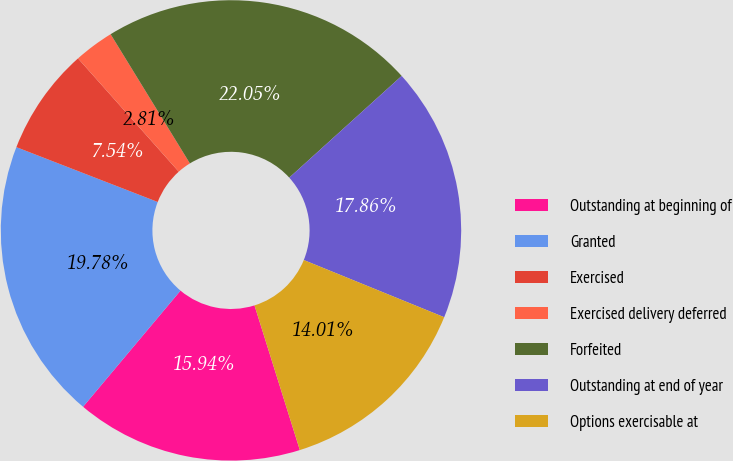Convert chart to OTSL. <chart><loc_0><loc_0><loc_500><loc_500><pie_chart><fcel>Outstanding at beginning of<fcel>Granted<fcel>Exercised<fcel>Exercised delivery deferred<fcel>Forfeited<fcel>Outstanding at end of year<fcel>Options exercisable at<nl><fcel>15.94%<fcel>19.78%<fcel>7.54%<fcel>2.81%<fcel>22.05%<fcel>17.86%<fcel>14.01%<nl></chart> 